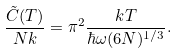Convert formula to latex. <formula><loc_0><loc_0><loc_500><loc_500>\frac { \tilde { C } ( T ) } { N k } = \pi ^ { 2 } \frac { k T } { \hbar { \omega } ( 6 N ) ^ { 1 / 3 } } .</formula> 